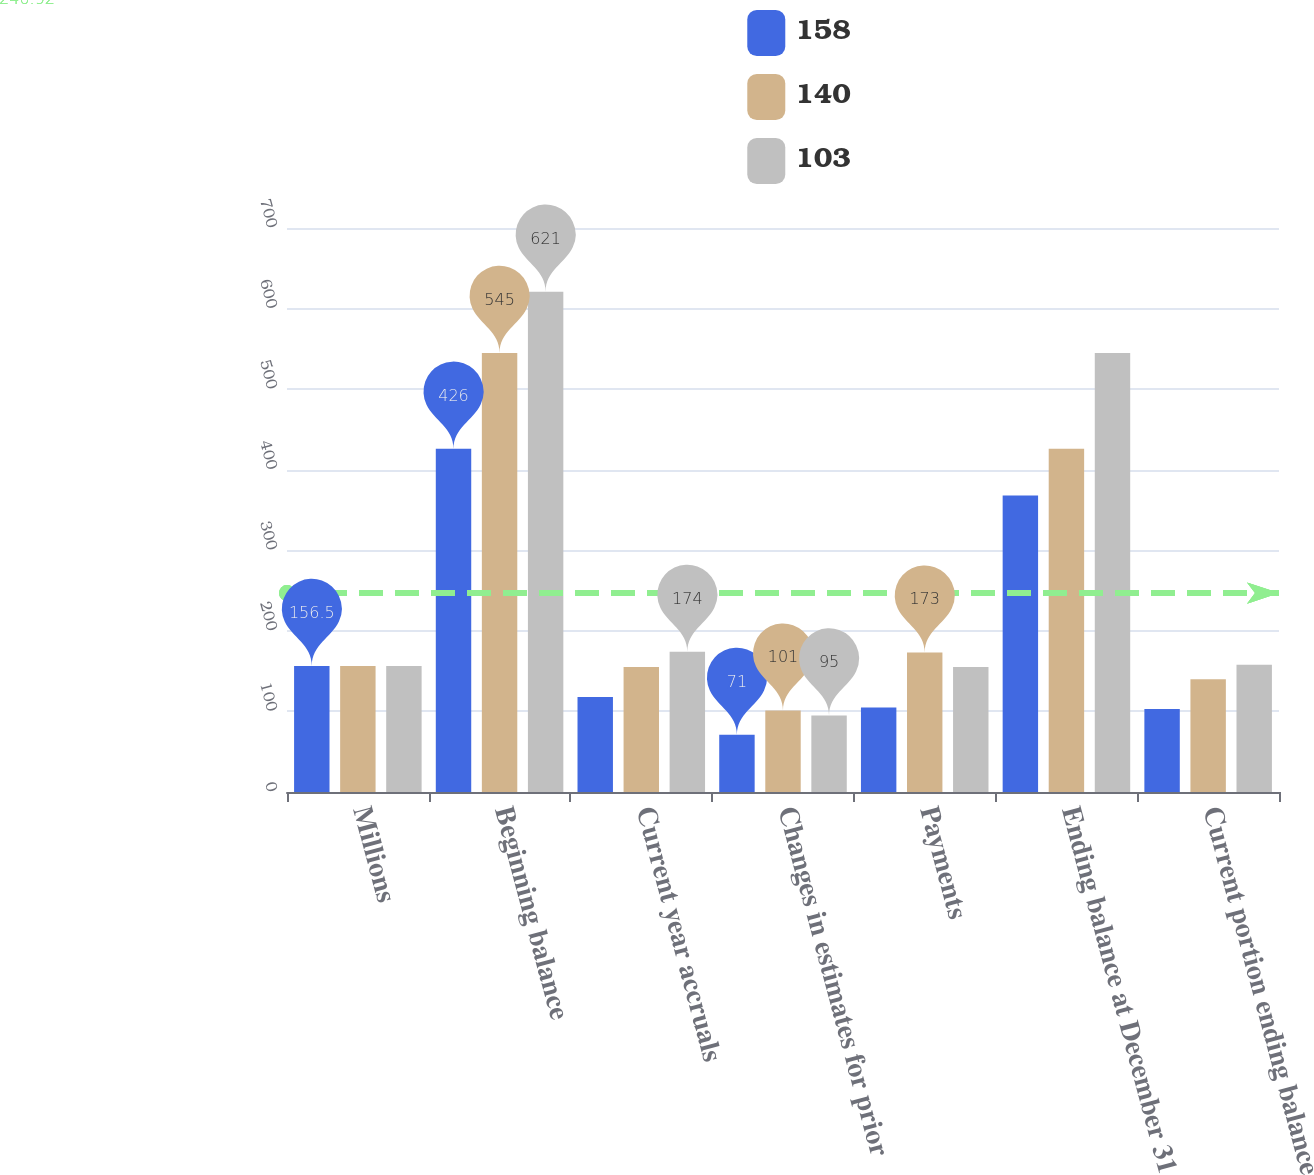<chart> <loc_0><loc_0><loc_500><loc_500><stacked_bar_chart><ecel><fcel>Millions<fcel>Beginning balance<fcel>Current year accruals<fcel>Changes in estimates for prior<fcel>Payments<fcel>Ending balance at December 31<fcel>Current portion ending balance<nl><fcel>158<fcel>156.5<fcel>426<fcel>118<fcel>71<fcel>105<fcel>368<fcel>103<nl><fcel>140<fcel>156.5<fcel>545<fcel>155<fcel>101<fcel>173<fcel>426<fcel>140<nl><fcel>103<fcel>156.5<fcel>621<fcel>174<fcel>95<fcel>155<fcel>545<fcel>158<nl></chart> 